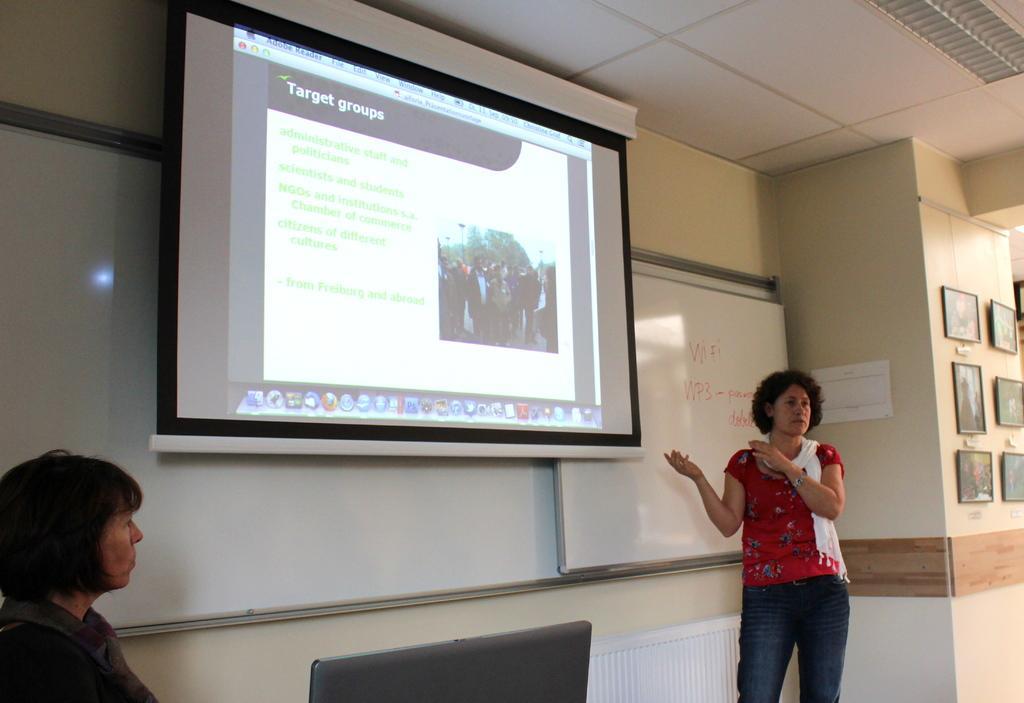Please provide a concise description of this image. In this picture I can see the two women on either side of this image, in the middle there is a projector screen. In the background there are boards, on the right side I can see the photo frames on the wall. 